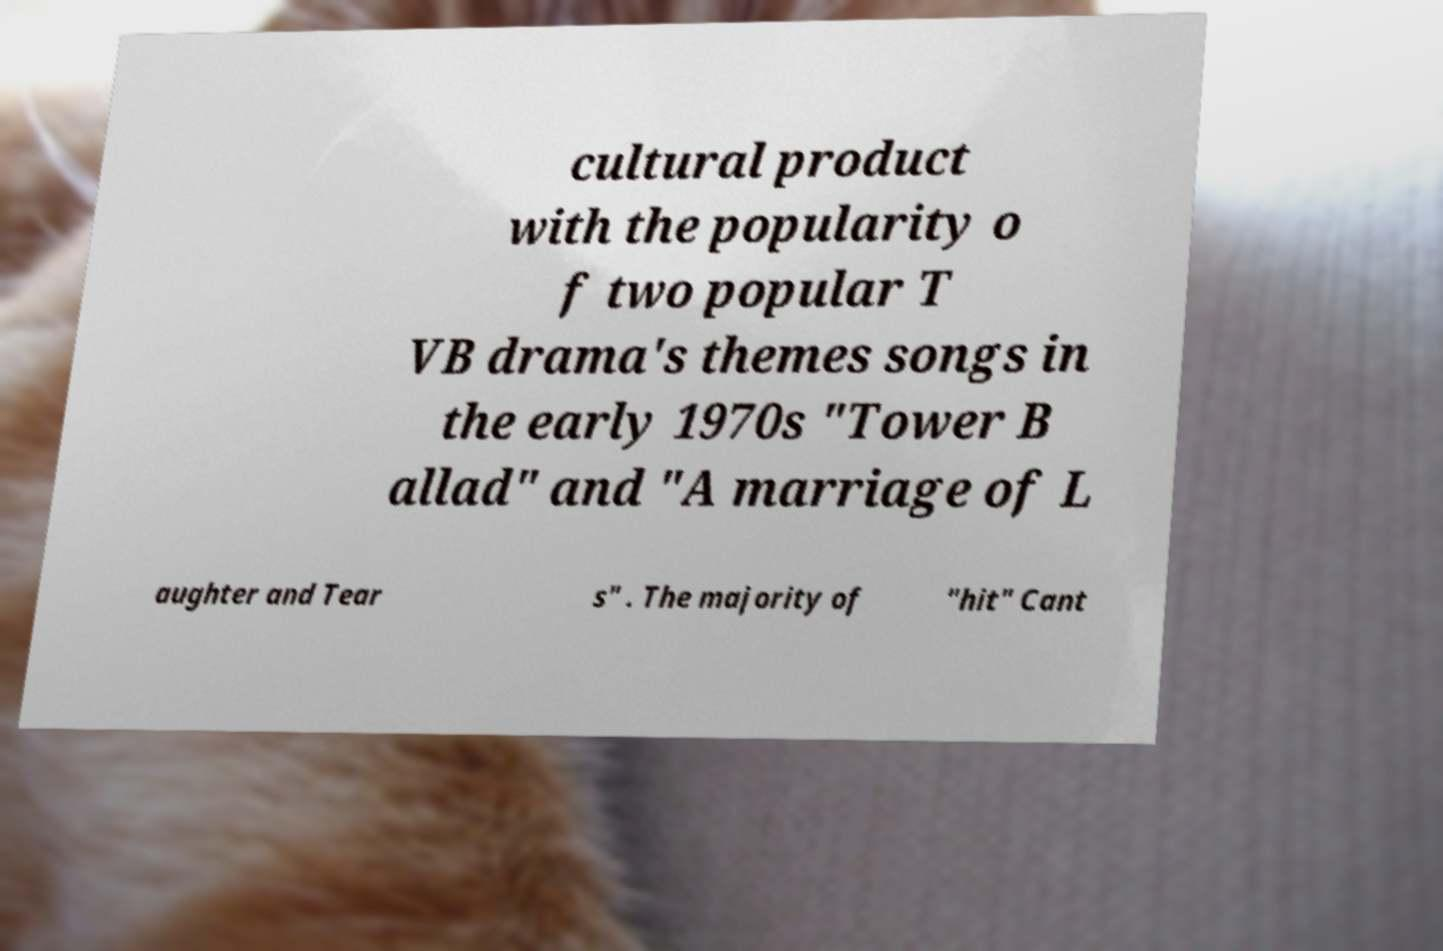Please identify and transcribe the text found in this image. cultural product with the popularity o f two popular T VB drama's themes songs in the early 1970s "Tower B allad" and "A marriage of L aughter and Tear s" . The majority of "hit" Cant 